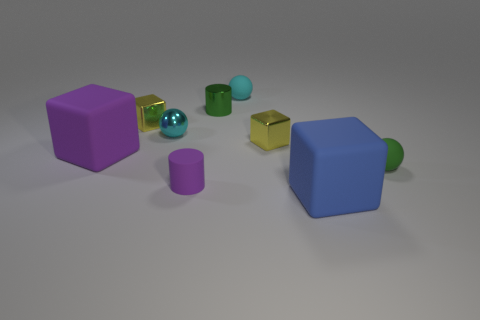How many balls are either big blue things or matte things?
Ensure brevity in your answer.  2. What is the shape of the object that is in front of the tiny metal sphere and behind the purple matte block?
Offer a terse response. Cube. Is there a purple rubber sphere that has the same size as the green sphere?
Keep it short and to the point. No. How many things are shiny things to the right of the cyan rubber sphere or cyan objects?
Keep it short and to the point. 3. Are the green cylinder and the tiny ball that is right of the small cyan matte thing made of the same material?
Offer a terse response. No. What number of other things are there of the same shape as the tiny cyan shiny thing?
Give a very brief answer. 2. How many things are either yellow metallic cubes on the left side of the purple rubber cylinder or cylinders behind the tiny green sphere?
Your response must be concise. 2. What number of other things are the same color as the metallic sphere?
Your response must be concise. 1. Is the number of small matte balls in front of the green metal cylinder less than the number of green rubber balls that are to the left of the big purple matte cube?
Offer a very short reply. No. How many tiny rubber spheres are there?
Offer a very short reply. 2. 